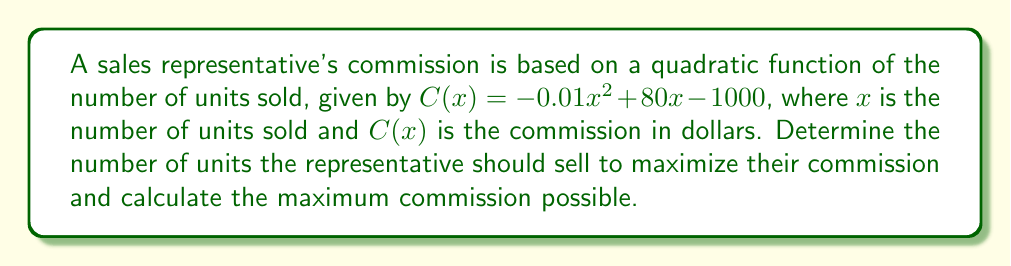What is the answer to this math problem? To find the optimal number of units to sell and the maximum commission, we need to use calculus optimization techniques:

1. Find the derivative of the commission function:
   $$C'(x) = -0.02x + 80$$

2. Set the derivative equal to zero to find the critical point:
   $$-0.02x + 80 = 0$$
   $$-0.02x = -80$$
   $$x = 4000$$

3. Verify that this critical point is a maximum by checking the second derivative:
   $$C''(x) = -0.02$$
   Since $C''(x)$ is negative, the critical point is a maximum.

4. Calculate the maximum commission by plugging $x = 4000$ into the original function:
   $$C(4000) = -0.01(4000)^2 + 80(4000) - 1000$$
   $$= -160000 + 320000 - 1000$$
   $$= 159000$$

Therefore, the optimal number of units to sell is 4000, and the maximum commission possible is $159,000.
Answer: 4000 units; $159,000 